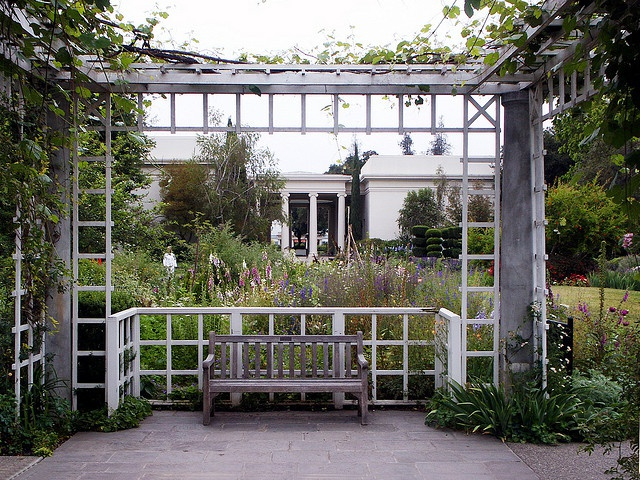Describe the objects in this image and their specific colors. I can see bench in black, gray, darkgray, and darkgreen tones and people in black, lavender, darkgray, gray, and darkgreen tones in this image. 